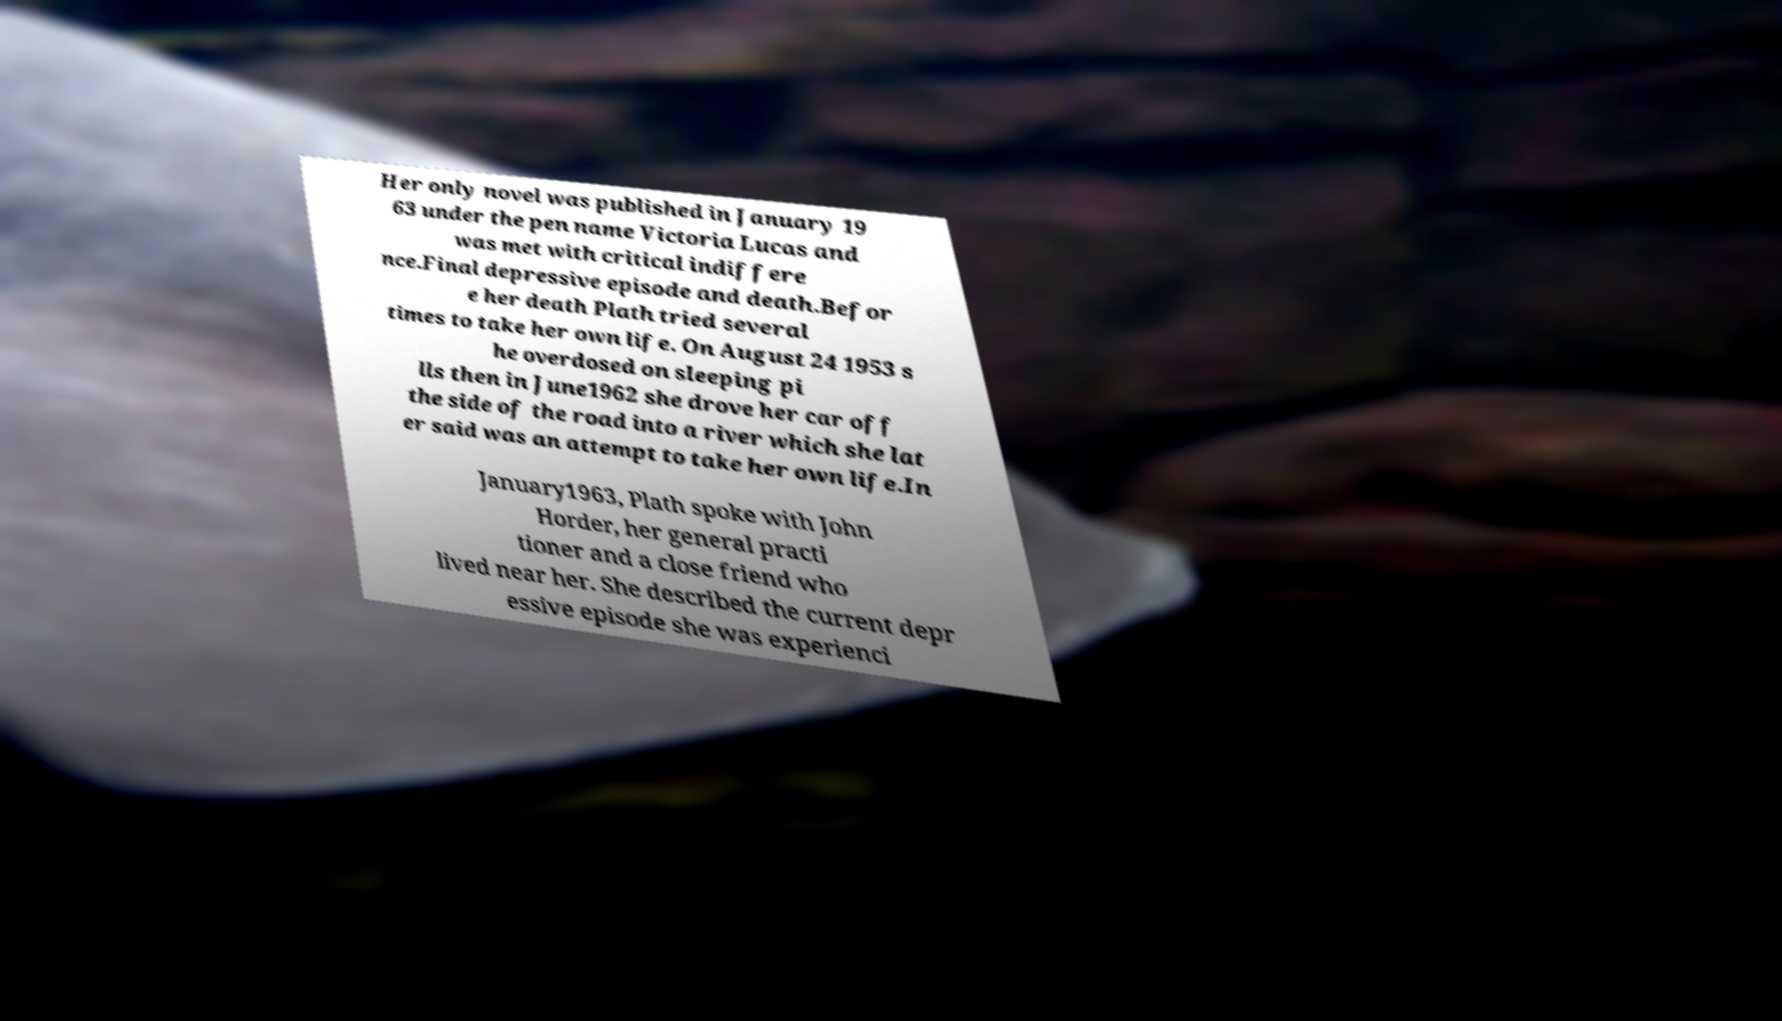Can you read and provide the text displayed in the image?This photo seems to have some interesting text. Can you extract and type it out for me? Her only novel was published in January 19 63 under the pen name Victoria Lucas and was met with critical indiffere nce.Final depressive episode and death.Befor e her death Plath tried several times to take her own life. On August 24 1953 s he overdosed on sleeping pi lls then in June1962 she drove her car off the side of the road into a river which she lat er said was an attempt to take her own life.In January1963, Plath spoke with John Horder, her general practi tioner and a close friend who lived near her. She described the current depr essive episode she was experienci 